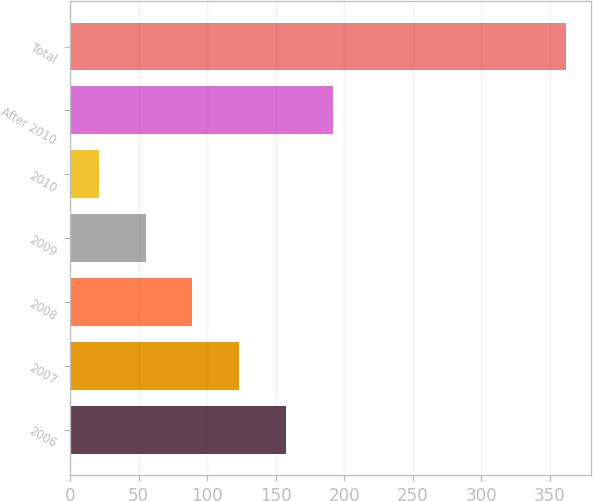Convert chart. <chart><loc_0><loc_0><loc_500><loc_500><bar_chart><fcel>2006<fcel>2007<fcel>2008<fcel>2009<fcel>2010<fcel>After 2010<fcel>Total<nl><fcel>157.4<fcel>123.3<fcel>89.2<fcel>55.1<fcel>21<fcel>191.5<fcel>362<nl></chart> 